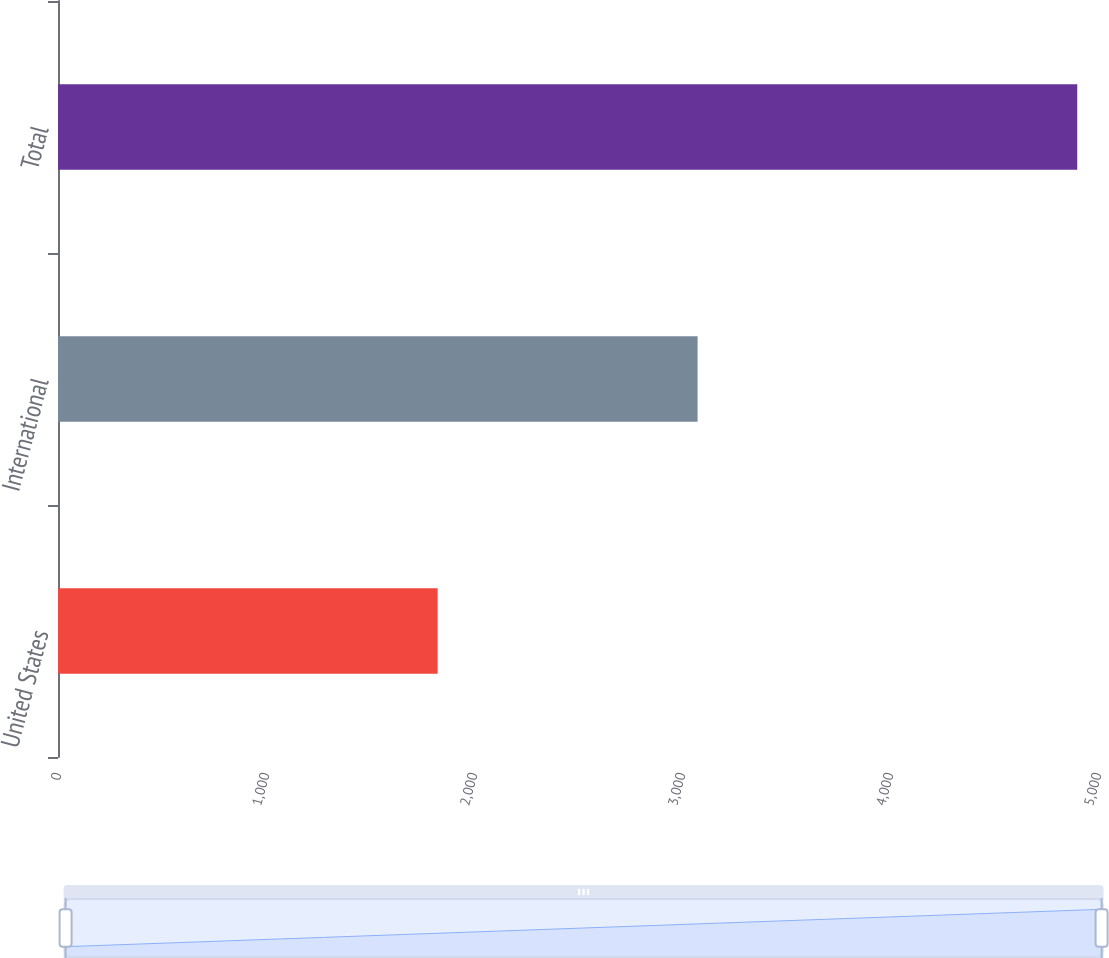<chart> <loc_0><loc_0><loc_500><loc_500><bar_chart><fcel>United States<fcel>International<fcel>Total<nl><fcel>1825.3<fcel>3074.9<fcel>4900.2<nl></chart> 